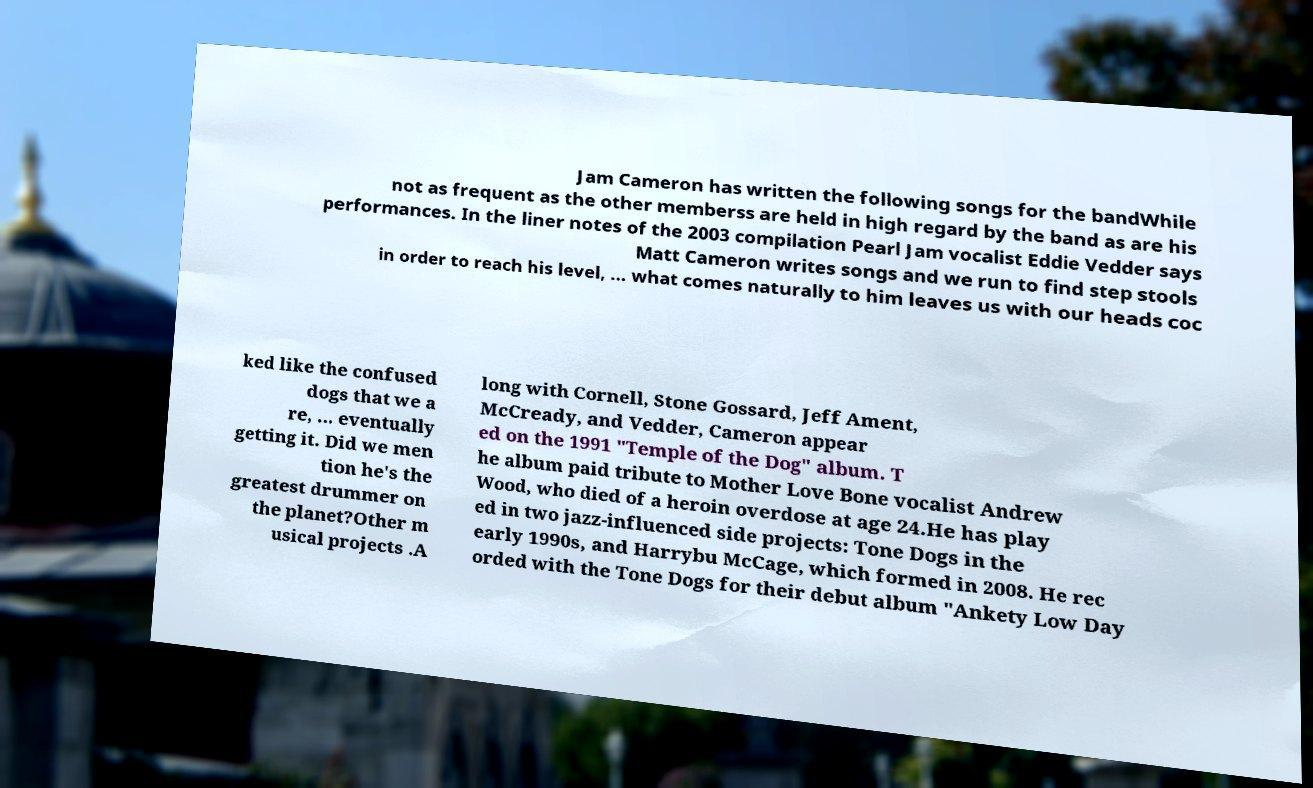Please read and relay the text visible in this image. What does it say? Jam Cameron has written the following songs for the bandWhile not as frequent as the other memberss are held in high regard by the band as are his performances. In the liner notes of the 2003 compilation Pearl Jam vocalist Eddie Vedder says Matt Cameron writes songs and we run to find step stools in order to reach his level, ... what comes naturally to him leaves us with our heads coc ked like the confused dogs that we a re, ... eventually getting it. Did we men tion he's the greatest drummer on the planet?Other m usical projects .A long with Cornell, Stone Gossard, Jeff Ament, McCready, and Vedder, Cameron appear ed on the 1991 "Temple of the Dog" album. T he album paid tribute to Mother Love Bone vocalist Andrew Wood, who died of a heroin overdose at age 24.He has play ed in two jazz-influenced side projects: Tone Dogs in the early 1990s, and Harrybu McCage, which formed in 2008. He rec orded with the Tone Dogs for their debut album "Ankety Low Day 